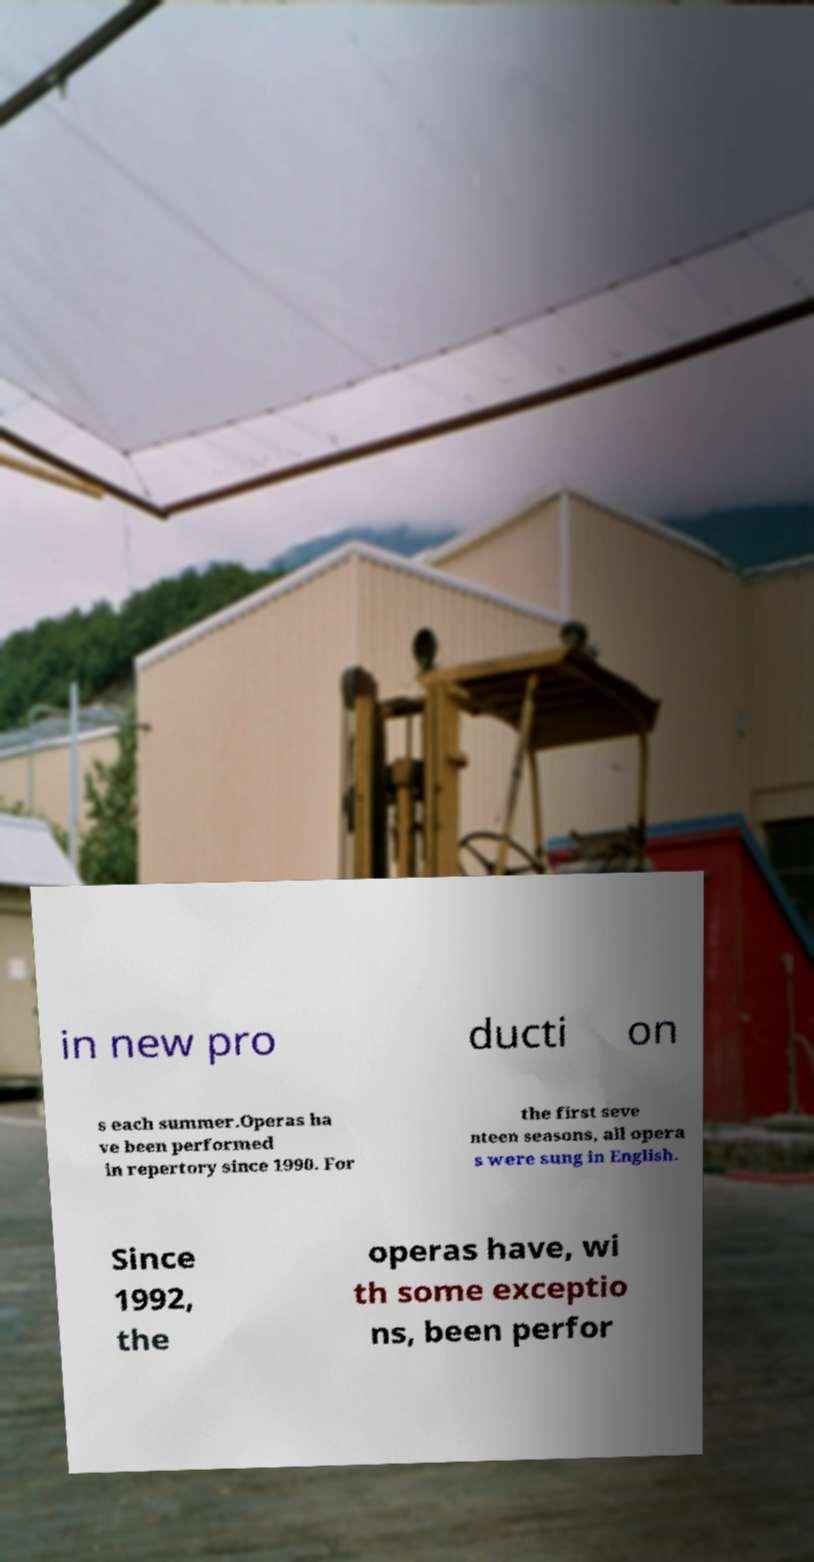Could you extract and type out the text from this image? in new pro ducti on s each summer.Operas ha ve been performed in repertory since 1990. For the first seve nteen seasons, all opera s were sung in English. Since 1992, the operas have, wi th some exceptio ns, been perfor 